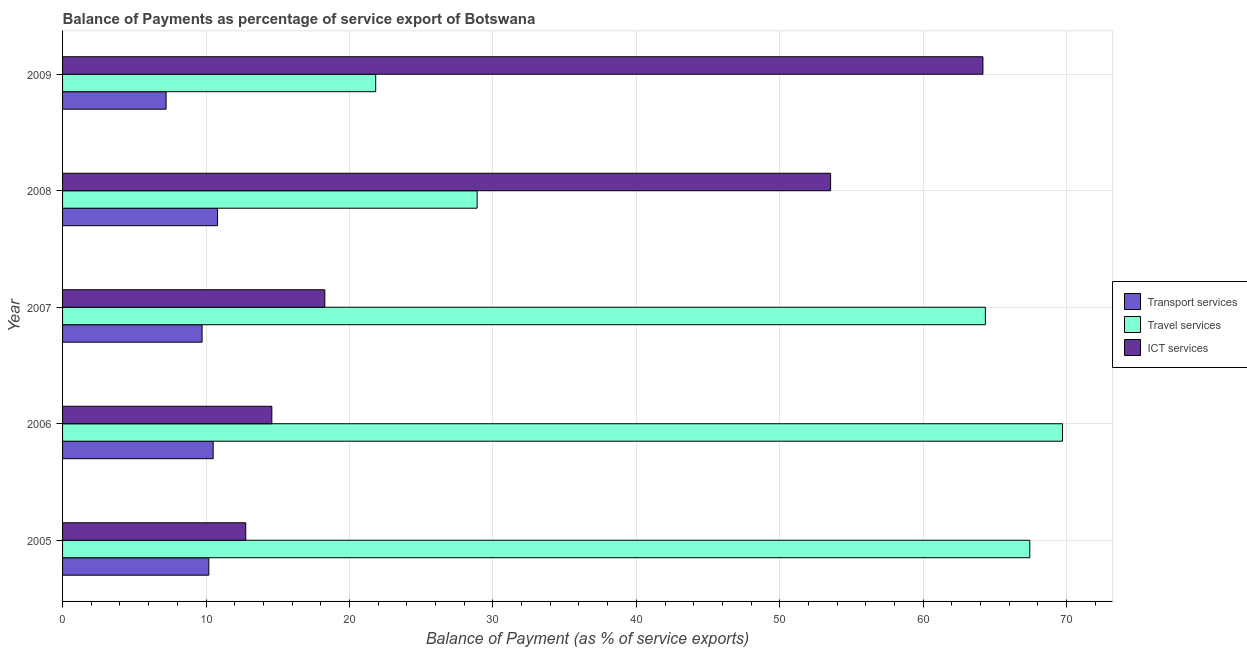How many groups of bars are there?
Make the answer very short. 5. How many bars are there on the 5th tick from the bottom?
Your response must be concise. 3. What is the label of the 2nd group of bars from the top?
Offer a terse response. 2008. In how many cases, is the number of bars for a given year not equal to the number of legend labels?
Your answer should be very brief. 0. What is the balance of payment of ict services in 2005?
Provide a short and direct response. 12.77. Across all years, what is the maximum balance of payment of ict services?
Keep it short and to the point. 64.16. Across all years, what is the minimum balance of payment of travel services?
Your response must be concise. 21.83. What is the total balance of payment of transport services in the graph?
Give a very brief answer. 48.44. What is the difference between the balance of payment of ict services in 2006 and that in 2007?
Keep it short and to the point. -3.69. What is the difference between the balance of payment of travel services in 2007 and the balance of payment of ict services in 2009?
Keep it short and to the point. 0.17. What is the average balance of payment of transport services per year?
Offer a terse response. 9.69. In the year 2007, what is the difference between the balance of payment of travel services and balance of payment of ict services?
Your answer should be compact. 46.05. What is the ratio of the balance of payment of transport services in 2006 to that in 2009?
Provide a succinct answer. 1.45. Is the balance of payment of transport services in 2006 less than that in 2008?
Keep it short and to the point. Yes. Is the difference between the balance of payment of transport services in 2007 and 2009 greater than the difference between the balance of payment of ict services in 2007 and 2009?
Provide a succinct answer. Yes. What is the difference between the highest and the second highest balance of payment of travel services?
Keep it short and to the point. 2.28. What is the difference between the highest and the lowest balance of payment of travel services?
Your answer should be compact. 47.88. What does the 3rd bar from the top in 2005 represents?
Keep it short and to the point. Transport services. What does the 2nd bar from the bottom in 2005 represents?
Your answer should be very brief. Travel services. Is it the case that in every year, the sum of the balance of payment of transport services and balance of payment of travel services is greater than the balance of payment of ict services?
Offer a very short reply. No. How many bars are there?
Provide a short and direct response. 15. Are all the bars in the graph horizontal?
Provide a succinct answer. Yes. Are the values on the major ticks of X-axis written in scientific E-notation?
Provide a succinct answer. No. Does the graph contain grids?
Offer a very short reply. Yes. How are the legend labels stacked?
Keep it short and to the point. Vertical. What is the title of the graph?
Your response must be concise. Balance of Payments as percentage of service export of Botswana. Does "Unpaid family workers" appear as one of the legend labels in the graph?
Your response must be concise. No. What is the label or title of the X-axis?
Ensure brevity in your answer.  Balance of Payment (as % of service exports). What is the Balance of Payment (as % of service exports) in Transport services in 2005?
Provide a short and direct response. 10.2. What is the Balance of Payment (as % of service exports) in Travel services in 2005?
Keep it short and to the point. 67.43. What is the Balance of Payment (as % of service exports) in ICT services in 2005?
Ensure brevity in your answer.  12.77. What is the Balance of Payment (as % of service exports) in Transport services in 2006?
Ensure brevity in your answer.  10.5. What is the Balance of Payment (as % of service exports) of Travel services in 2006?
Ensure brevity in your answer.  69.71. What is the Balance of Payment (as % of service exports) of ICT services in 2006?
Provide a short and direct response. 14.59. What is the Balance of Payment (as % of service exports) in Transport services in 2007?
Your answer should be very brief. 9.73. What is the Balance of Payment (as % of service exports) of Travel services in 2007?
Provide a succinct answer. 64.33. What is the Balance of Payment (as % of service exports) of ICT services in 2007?
Your answer should be compact. 18.28. What is the Balance of Payment (as % of service exports) of Transport services in 2008?
Your answer should be compact. 10.8. What is the Balance of Payment (as % of service exports) in Travel services in 2008?
Make the answer very short. 28.9. What is the Balance of Payment (as % of service exports) of ICT services in 2008?
Offer a very short reply. 53.54. What is the Balance of Payment (as % of service exports) of Transport services in 2009?
Your response must be concise. 7.22. What is the Balance of Payment (as % of service exports) of Travel services in 2009?
Ensure brevity in your answer.  21.83. What is the Balance of Payment (as % of service exports) of ICT services in 2009?
Ensure brevity in your answer.  64.16. Across all years, what is the maximum Balance of Payment (as % of service exports) of Transport services?
Ensure brevity in your answer.  10.8. Across all years, what is the maximum Balance of Payment (as % of service exports) in Travel services?
Offer a terse response. 69.71. Across all years, what is the maximum Balance of Payment (as % of service exports) in ICT services?
Your response must be concise. 64.16. Across all years, what is the minimum Balance of Payment (as % of service exports) of Transport services?
Your answer should be compact. 7.22. Across all years, what is the minimum Balance of Payment (as % of service exports) in Travel services?
Offer a very short reply. 21.83. Across all years, what is the minimum Balance of Payment (as % of service exports) in ICT services?
Your response must be concise. 12.77. What is the total Balance of Payment (as % of service exports) of Transport services in the graph?
Give a very brief answer. 48.44. What is the total Balance of Payment (as % of service exports) in Travel services in the graph?
Your answer should be compact. 252.21. What is the total Balance of Payment (as % of service exports) of ICT services in the graph?
Keep it short and to the point. 163.35. What is the difference between the Balance of Payment (as % of service exports) of Transport services in 2005 and that in 2006?
Provide a short and direct response. -0.3. What is the difference between the Balance of Payment (as % of service exports) in Travel services in 2005 and that in 2006?
Your answer should be compact. -2.28. What is the difference between the Balance of Payment (as % of service exports) of ICT services in 2005 and that in 2006?
Your answer should be compact. -1.82. What is the difference between the Balance of Payment (as % of service exports) in Transport services in 2005 and that in 2007?
Ensure brevity in your answer.  0.47. What is the difference between the Balance of Payment (as % of service exports) of Travel services in 2005 and that in 2007?
Offer a terse response. 3.1. What is the difference between the Balance of Payment (as % of service exports) in ICT services in 2005 and that in 2007?
Offer a very short reply. -5.51. What is the difference between the Balance of Payment (as % of service exports) in Transport services in 2005 and that in 2008?
Provide a short and direct response. -0.61. What is the difference between the Balance of Payment (as % of service exports) in Travel services in 2005 and that in 2008?
Offer a terse response. 38.53. What is the difference between the Balance of Payment (as % of service exports) of ICT services in 2005 and that in 2008?
Provide a succinct answer. -40.77. What is the difference between the Balance of Payment (as % of service exports) in Transport services in 2005 and that in 2009?
Provide a short and direct response. 2.98. What is the difference between the Balance of Payment (as % of service exports) in Travel services in 2005 and that in 2009?
Make the answer very short. 45.6. What is the difference between the Balance of Payment (as % of service exports) in ICT services in 2005 and that in 2009?
Offer a terse response. -51.39. What is the difference between the Balance of Payment (as % of service exports) of Transport services in 2006 and that in 2007?
Ensure brevity in your answer.  0.77. What is the difference between the Balance of Payment (as % of service exports) of Travel services in 2006 and that in 2007?
Make the answer very short. 5.38. What is the difference between the Balance of Payment (as % of service exports) of ICT services in 2006 and that in 2007?
Offer a very short reply. -3.69. What is the difference between the Balance of Payment (as % of service exports) of Transport services in 2006 and that in 2008?
Make the answer very short. -0.31. What is the difference between the Balance of Payment (as % of service exports) of Travel services in 2006 and that in 2008?
Keep it short and to the point. 40.81. What is the difference between the Balance of Payment (as % of service exports) of ICT services in 2006 and that in 2008?
Make the answer very short. -38.95. What is the difference between the Balance of Payment (as % of service exports) of Transport services in 2006 and that in 2009?
Your answer should be very brief. 3.28. What is the difference between the Balance of Payment (as % of service exports) in Travel services in 2006 and that in 2009?
Keep it short and to the point. 47.88. What is the difference between the Balance of Payment (as % of service exports) of ICT services in 2006 and that in 2009?
Your answer should be very brief. -49.57. What is the difference between the Balance of Payment (as % of service exports) in Transport services in 2007 and that in 2008?
Make the answer very short. -1.08. What is the difference between the Balance of Payment (as % of service exports) in Travel services in 2007 and that in 2008?
Your response must be concise. 35.43. What is the difference between the Balance of Payment (as % of service exports) of ICT services in 2007 and that in 2008?
Ensure brevity in your answer.  -35.26. What is the difference between the Balance of Payment (as % of service exports) in Transport services in 2007 and that in 2009?
Keep it short and to the point. 2.51. What is the difference between the Balance of Payment (as % of service exports) of Travel services in 2007 and that in 2009?
Your answer should be very brief. 42.5. What is the difference between the Balance of Payment (as % of service exports) in ICT services in 2007 and that in 2009?
Offer a very short reply. -45.88. What is the difference between the Balance of Payment (as % of service exports) of Transport services in 2008 and that in 2009?
Your response must be concise. 3.59. What is the difference between the Balance of Payment (as % of service exports) in Travel services in 2008 and that in 2009?
Your response must be concise. 7.07. What is the difference between the Balance of Payment (as % of service exports) of ICT services in 2008 and that in 2009?
Provide a short and direct response. -10.62. What is the difference between the Balance of Payment (as % of service exports) in Transport services in 2005 and the Balance of Payment (as % of service exports) in Travel services in 2006?
Offer a terse response. -59.52. What is the difference between the Balance of Payment (as % of service exports) in Transport services in 2005 and the Balance of Payment (as % of service exports) in ICT services in 2006?
Provide a short and direct response. -4.39. What is the difference between the Balance of Payment (as % of service exports) of Travel services in 2005 and the Balance of Payment (as % of service exports) of ICT services in 2006?
Provide a short and direct response. 52.84. What is the difference between the Balance of Payment (as % of service exports) of Transport services in 2005 and the Balance of Payment (as % of service exports) of Travel services in 2007?
Make the answer very short. -54.14. What is the difference between the Balance of Payment (as % of service exports) of Transport services in 2005 and the Balance of Payment (as % of service exports) of ICT services in 2007?
Offer a very short reply. -8.09. What is the difference between the Balance of Payment (as % of service exports) of Travel services in 2005 and the Balance of Payment (as % of service exports) of ICT services in 2007?
Ensure brevity in your answer.  49.15. What is the difference between the Balance of Payment (as % of service exports) in Transport services in 2005 and the Balance of Payment (as % of service exports) in Travel services in 2008?
Your answer should be compact. -18.71. What is the difference between the Balance of Payment (as % of service exports) of Transport services in 2005 and the Balance of Payment (as % of service exports) of ICT services in 2008?
Make the answer very short. -43.35. What is the difference between the Balance of Payment (as % of service exports) of Travel services in 2005 and the Balance of Payment (as % of service exports) of ICT services in 2008?
Your response must be concise. 13.89. What is the difference between the Balance of Payment (as % of service exports) in Transport services in 2005 and the Balance of Payment (as % of service exports) in Travel services in 2009?
Keep it short and to the point. -11.63. What is the difference between the Balance of Payment (as % of service exports) in Transport services in 2005 and the Balance of Payment (as % of service exports) in ICT services in 2009?
Provide a succinct answer. -53.97. What is the difference between the Balance of Payment (as % of service exports) of Travel services in 2005 and the Balance of Payment (as % of service exports) of ICT services in 2009?
Provide a short and direct response. 3.27. What is the difference between the Balance of Payment (as % of service exports) in Transport services in 2006 and the Balance of Payment (as % of service exports) in Travel services in 2007?
Your answer should be compact. -53.84. What is the difference between the Balance of Payment (as % of service exports) of Transport services in 2006 and the Balance of Payment (as % of service exports) of ICT services in 2007?
Make the answer very short. -7.78. What is the difference between the Balance of Payment (as % of service exports) in Travel services in 2006 and the Balance of Payment (as % of service exports) in ICT services in 2007?
Make the answer very short. 51.43. What is the difference between the Balance of Payment (as % of service exports) of Transport services in 2006 and the Balance of Payment (as % of service exports) of Travel services in 2008?
Your answer should be compact. -18.4. What is the difference between the Balance of Payment (as % of service exports) of Transport services in 2006 and the Balance of Payment (as % of service exports) of ICT services in 2008?
Your response must be concise. -43.05. What is the difference between the Balance of Payment (as % of service exports) of Travel services in 2006 and the Balance of Payment (as % of service exports) of ICT services in 2008?
Your answer should be compact. 16.17. What is the difference between the Balance of Payment (as % of service exports) of Transport services in 2006 and the Balance of Payment (as % of service exports) of Travel services in 2009?
Keep it short and to the point. -11.33. What is the difference between the Balance of Payment (as % of service exports) of Transport services in 2006 and the Balance of Payment (as % of service exports) of ICT services in 2009?
Ensure brevity in your answer.  -53.66. What is the difference between the Balance of Payment (as % of service exports) of Travel services in 2006 and the Balance of Payment (as % of service exports) of ICT services in 2009?
Your answer should be compact. 5.55. What is the difference between the Balance of Payment (as % of service exports) in Transport services in 2007 and the Balance of Payment (as % of service exports) in Travel services in 2008?
Your answer should be compact. -19.17. What is the difference between the Balance of Payment (as % of service exports) of Transport services in 2007 and the Balance of Payment (as % of service exports) of ICT services in 2008?
Keep it short and to the point. -43.82. What is the difference between the Balance of Payment (as % of service exports) in Travel services in 2007 and the Balance of Payment (as % of service exports) in ICT services in 2008?
Provide a succinct answer. 10.79. What is the difference between the Balance of Payment (as % of service exports) in Transport services in 2007 and the Balance of Payment (as % of service exports) in Travel services in 2009?
Provide a succinct answer. -12.1. What is the difference between the Balance of Payment (as % of service exports) of Transport services in 2007 and the Balance of Payment (as % of service exports) of ICT services in 2009?
Your answer should be compact. -54.44. What is the difference between the Balance of Payment (as % of service exports) of Travel services in 2007 and the Balance of Payment (as % of service exports) of ICT services in 2009?
Ensure brevity in your answer.  0.17. What is the difference between the Balance of Payment (as % of service exports) of Transport services in 2008 and the Balance of Payment (as % of service exports) of Travel services in 2009?
Provide a succinct answer. -11.02. What is the difference between the Balance of Payment (as % of service exports) of Transport services in 2008 and the Balance of Payment (as % of service exports) of ICT services in 2009?
Ensure brevity in your answer.  -53.36. What is the difference between the Balance of Payment (as % of service exports) in Travel services in 2008 and the Balance of Payment (as % of service exports) in ICT services in 2009?
Keep it short and to the point. -35.26. What is the average Balance of Payment (as % of service exports) in Transport services per year?
Offer a terse response. 9.69. What is the average Balance of Payment (as % of service exports) of Travel services per year?
Your answer should be compact. 50.44. What is the average Balance of Payment (as % of service exports) of ICT services per year?
Your answer should be compact. 32.67. In the year 2005, what is the difference between the Balance of Payment (as % of service exports) of Transport services and Balance of Payment (as % of service exports) of Travel services?
Your answer should be compact. -57.24. In the year 2005, what is the difference between the Balance of Payment (as % of service exports) in Transport services and Balance of Payment (as % of service exports) in ICT services?
Your answer should be compact. -2.58. In the year 2005, what is the difference between the Balance of Payment (as % of service exports) of Travel services and Balance of Payment (as % of service exports) of ICT services?
Provide a short and direct response. 54.66. In the year 2006, what is the difference between the Balance of Payment (as % of service exports) in Transport services and Balance of Payment (as % of service exports) in Travel services?
Your answer should be very brief. -59.21. In the year 2006, what is the difference between the Balance of Payment (as % of service exports) of Transport services and Balance of Payment (as % of service exports) of ICT services?
Give a very brief answer. -4.09. In the year 2006, what is the difference between the Balance of Payment (as % of service exports) of Travel services and Balance of Payment (as % of service exports) of ICT services?
Provide a short and direct response. 55.12. In the year 2007, what is the difference between the Balance of Payment (as % of service exports) of Transport services and Balance of Payment (as % of service exports) of Travel services?
Your answer should be compact. -54.61. In the year 2007, what is the difference between the Balance of Payment (as % of service exports) of Transport services and Balance of Payment (as % of service exports) of ICT services?
Offer a terse response. -8.55. In the year 2007, what is the difference between the Balance of Payment (as % of service exports) in Travel services and Balance of Payment (as % of service exports) in ICT services?
Offer a terse response. 46.05. In the year 2008, what is the difference between the Balance of Payment (as % of service exports) in Transport services and Balance of Payment (as % of service exports) in Travel services?
Your answer should be compact. -18.1. In the year 2008, what is the difference between the Balance of Payment (as % of service exports) of Transport services and Balance of Payment (as % of service exports) of ICT services?
Keep it short and to the point. -42.74. In the year 2008, what is the difference between the Balance of Payment (as % of service exports) in Travel services and Balance of Payment (as % of service exports) in ICT services?
Your response must be concise. -24.64. In the year 2009, what is the difference between the Balance of Payment (as % of service exports) in Transport services and Balance of Payment (as % of service exports) in Travel services?
Provide a short and direct response. -14.61. In the year 2009, what is the difference between the Balance of Payment (as % of service exports) in Transport services and Balance of Payment (as % of service exports) in ICT services?
Make the answer very short. -56.94. In the year 2009, what is the difference between the Balance of Payment (as % of service exports) in Travel services and Balance of Payment (as % of service exports) in ICT services?
Your response must be concise. -42.33. What is the ratio of the Balance of Payment (as % of service exports) of Transport services in 2005 to that in 2006?
Give a very brief answer. 0.97. What is the ratio of the Balance of Payment (as % of service exports) of Travel services in 2005 to that in 2006?
Offer a very short reply. 0.97. What is the ratio of the Balance of Payment (as % of service exports) in ICT services in 2005 to that in 2006?
Keep it short and to the point. 0.88. What is the ratio of the Balance of Payment (as % of service exports) in Transport services in 2005 to that in 2007?
Make the answer very short. 1.05. What is the ratio of the Balance of Payment (as % of service exports) of Travel services in 2005 to that in 2007?
Provide a short and direct response. 1.05. What is the ratio of the Balance of Payment (as % of service exports) in ICT services in 2005 to that in 2007?
Give a very brief answer. 0.7. What is the ratio of the Balance of Payment (as % of service exports) of Transport services in 2005 to that in 2008?
Your response must be concise. 0.94. What is the ratio of the Balance of Payment (as % of service exports) of Travel services in 2005 to that in 2008?
Your response must be concise. 2.33. What is the ratio of the Balance of Payment (as % of service exports) in ICT services in 2005 to that in 2008?
Offer a very short reply. 0.24. What is the ratio of the Balance of Payment (as % of service exports) in Transport services in 2005 to that in 2009?
Give a very brief answer. 1.41. What is the ratio of the Balance of Payment (as % of service exports) in Travel services in 2005 to that in 2009?
Give a very brief answer. 3.09. What is the ratio of the Balance of Payment (as % of service exports) in ICT services in 2005 to that in 2009?
Offer a terse response. 0.2. What is the ratio of the Balance of Payment (as % of service exports) of Transport services in 2006 to that in 2007?
Keep it short and to the point. 1.08. What is the ratio of the Balance of Payment (as % of service exports) in Travel services in 2006 to that in 2007?
Your response must be concise. 1.08. What is the ratio of the Balance of Payment (as % of service exports) in ICT services in 2006 to that in 2007?
Give a very brief answer. 0.8. What is the ratio of the Balance of Payment (as % of service exports) in Transport services in 2006 to that in 2008?
Keep it short and to the point. 0.97. What is the ratio of the Balance of Payment (as % of service exports) of Travel services in 2006 to that in 2008?
Your response must be concise. 2.41. What is the ratio of the Balance of Payment (as % of service exports) of ICT services in 2006 to that in 2008?
Provide a short and direct response. 0.27. What is the ratio of the Balance of Payment (as % of service exports) of Transport services in 2006 to that in 2009?
Your response must be concise. 1.45. What is the ratio of the Balance of Payment (as % of service exports) in Travel services in 2006 to that in 2009?
Ensure brevity in your answer.  3.19. What is the ratio of the Balance of Payment (as % of service exports) in ICT services in 2006 to that in 2009?
Provide a short and direct response. 0.23. What is the ratio of the Balance of Payment (as % of service exports) of Transport services in 2007 to that in 2008?
Make the answer very short. 0.9. What is the ratio of the Balance of Payment (as % of service exports) in Travel services in 2007 to that in 2008?
Offer a terse response. 2.23. What is the ratio of the Balance of Payment (as % of service exports) of ICT services in 2007 to that in 2008?
Your response must be concise. 0.34. What is the ratio of the Balance of Payment (as % of service exports) of Transport services in 2007 to that in 2009?
Your answer should be compact. 1.35. What is the ratio of the Balance of Payment (as % of service exports) in Travel services in 2007 to that in 2009?
Your answer should be very brief. 2.95. What is the ratio of the Balance of Payment (as % of service exports) of ICT services in 2007 to that in 2009?
Your response must be concise. 0.28. What is the ratio of the Balance of Payment (as % of service exports) in Transport services in 2008 to that in 2009?
Offer a terse response. 1.5. What is the ratio of the Balance of Payment (as % of service exports) of Travel services in 2008 to that in 2009?
Give a very brief answer. 1.32. What is the ratio of the Balance of Payment (as % of service exports) of ICT services in 2008 to that in 2009?
Make the answer very short. 0.83. What is the difference between the highest and the second highest Balance of Payment (as % of service exports) in Transport services?
Give a very brief answer. 0.31. What is the difference between the highest and the second highest Balance of Payment (as % of service exports) in Travel services?
Give a very brief answer. 2.28. What is the difference between the highest and the second highest Balance of Payment (as % of service exports) of ICT services?
Offer a terse response. 10.62. What is the difference between the highest and the lowest Balance of Payment (as % of service exports) in Transport services?
Make the answer very short. 3.59. What is the difference between the highest and the lowest Balance of Payment (as % of service exports) of Travel services?
Provide a succinct answer. 47.88. What is the difference between the highest and the lowest Balance of Payment (as % of service exports) of ICT services?
Your answer should be very brief. 51.39. 